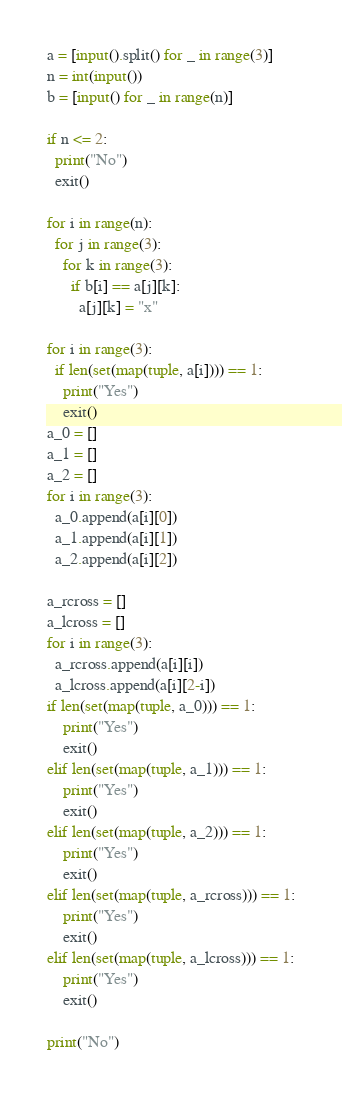<code> <loc_0><loc_0><loc_500><loc_500><_Python_>a = [input().split() for _ in range(3)]
n = int(input())
b = [input() for _ in range(n)]

if n <= 2:
  print("No")
  exit()

for i in range(n):
  for j in range(3):
    for k in range(3):
      if b[i] == a[j][k]:
        a[j][k] = "x"

for i in range(3):
  if len(set(map(tuple, a[i]))) == 1:
    print("Yes")
    exit()
a_0 = []
a_1 = []
a_2 = []
for i in range(3):
  a_0.append(a[i][0])
  a_1.append(a[i][1])
  a_2.append(a[i][2])

a_rcross = []
a_lcross = []
for i in range(3):
  a_rcross.append(a[i][i])
  a_lcross.append(a[i][2-i])
if len(set(map(tuple, a_0))) == 1:
    print("Yes")
    exit()
elif len(set(map(tuple, a_1))) == 1:
    print("Yes")
    exit()
elif len(set(map(tuple, a_2))) == 1:
    print("Yes")
    exit()
elif len(set(map(tuple, a_rcross))) == 1:
    print("Yes")
    exit()
elif len(set(map(tuple, a_lcross))) == 1:
    print("Yes")
    exit()
    
print("No")</code> 